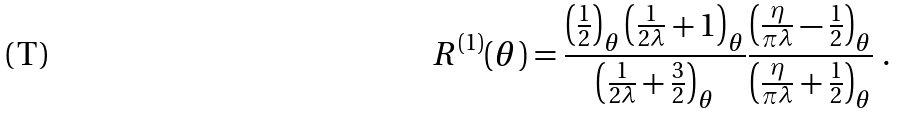<formula> <loc_0><loc_0><loc_500><loc_500>R ^ { ( 1 ) } ( \theta ) = \frac { \left ( \frac { 1 } { 2 } \right ) _ { \theta } \left ( \frac { 1 } { 2 \lambda } + 1 \right ) _ { \theta } } { \left ( \frac { 1 } { 2 \lambda } + \frac { 3 } { 2 } \right ) _ { \theta } } \frac { \left ( \frac { \eta } { \pi \lambda } - \frac { 1 } { 2 } \right ) _ { \theta } } { \left ( \frac { \eta } { \pi \lambda } + \frac { 1 } { 2 } \right ) _ { \theta } } \ .</formula> 